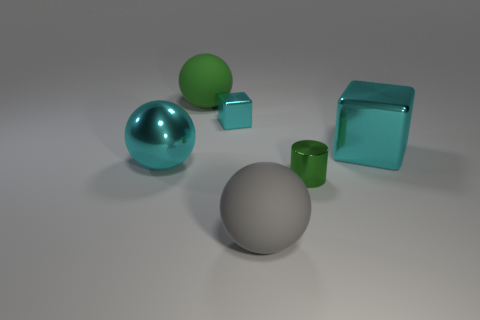Add 3 green rubber blocks. How many objects exist? 9 Subtract all cyan spheres. How many spheres are left? 2 Add 6 big cyan metal balls. How many big cyan metal balls are left? 7 Add 3 large red metallic balls. How many large red metallic balls exist? 3 Subtract all cyan spheres. How many spheres are left? 2 Subtract 0 red cylinders. How many objects are left? 6 Subtract all cylinders. How many objects are left? 5 Subtract all gray cubes. Subtract all brown cylinders. How many cubes are left? 2 Subtract all yellow cylinders. How many purple cubes are left? 0 Subtract all large metallic blocks. Subtract all small things. How many objects are left? 3 